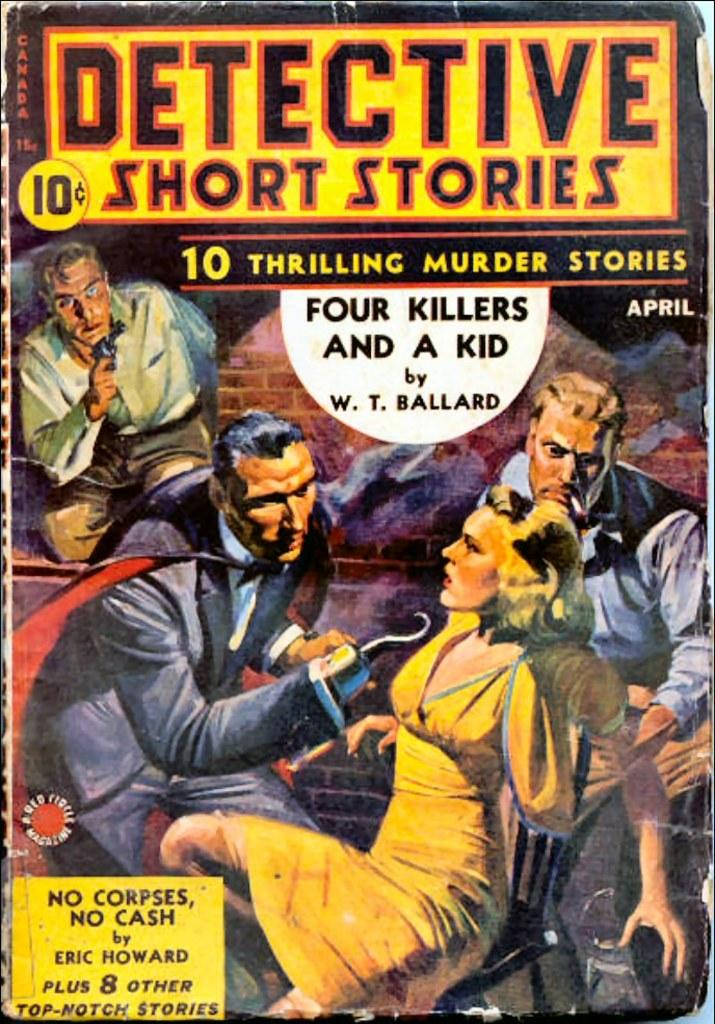<image>
Create a compact narrative representing the image presented. A colorful short stories paperback book that was original sold for 10 cents. 